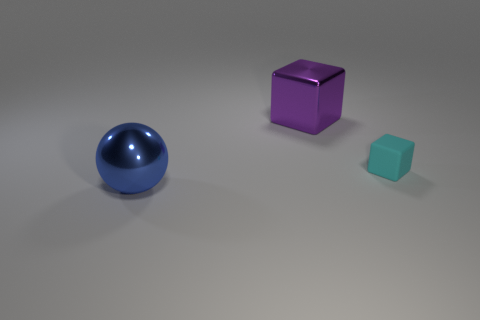Are there any large objects right of the blue shiny object?
Ensure brevity in your answer.  Yes. Are there any tiny rubber cubes that are on the right side of the large metallic block to the right of the sphere?
Offer a very short reply. Yes. Does the metallic thing in front of the tiny thing have the same size as the cube in front of the large purple block?
Give a very brief answer. No. What number of tiny things are red objects or metal balls?
Your answer should be very brief. 0. The block that is in front of the cube behind the small block is made of what material?
Give a very brief answer. Rubber. Are there any blocks made of the same material as the big blue thing?
Offer a terse response. Yes. Is the material of the large blue ball the same as the big object that is behind the big blue ball?
Offer a very short reply. Yes. What color is the shiny cube that is the same size as the blue metallic thing?
Ensure brevity in your answer.  Purple. What is the size of the purple metal object that is behind the cube in front of the big purple metallic object?
Make the answer very short. Large. Are there fewer rubber blocks on the right side of the small block than balls?
Your answer should be very brief. Yes. 